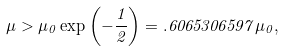Convert formula to latex. <formula><loc_0><loc_0><loc_500><loc_500>\mu > \mu _ { 0 } \exp \left ( - \frac { 1 } { 2 } \right ) = . 6 0 6 5 3 0 6 5 9 7 \mu _ { 0 } ,</formula> 